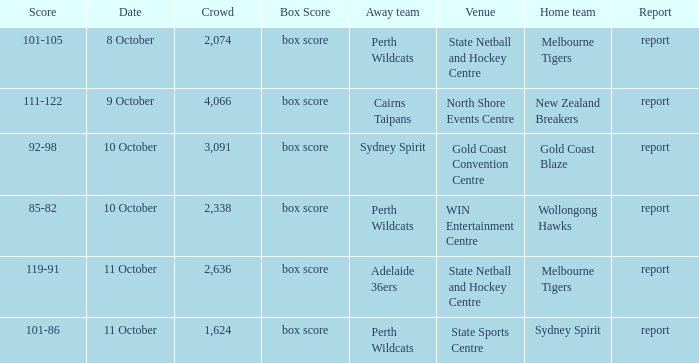What was the average crowd size for the game when the Gold Coast Blaze was the home team? 3091.0. 